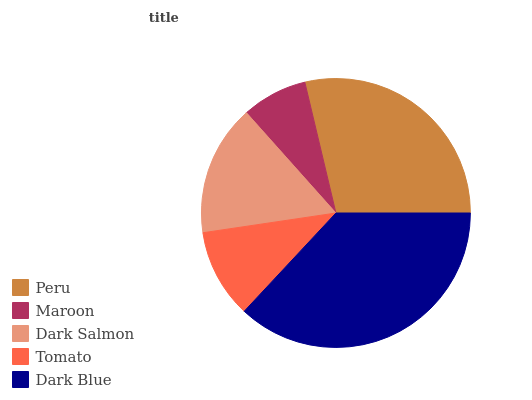Is Maroon the minimum?
Answer yes or no. Yes. Is Dark Blue the maximum?
Answer yes or no. Yes. Is Dark Salmon the minimum?
Answer yes or no. No. Is Dark Salmon the maximum?
Answer yes or no. No. Is Dark Salmon greater than Maroon?
Answer yes or no. Yes. Is Maroon less than Dark Salmon?
Answer yes or no. Yes. Is Maroon greater than Dark Salmon?
Answer yes or no. No. Is Dark Salmon less than Maroon?
Answer yes or no. No. Is Dark Salmon the high median?
Answer yes or no. Yes. Is Dark Salmon the low median?
Answer yes or no. Yes. Is Peru the high median?
Answer yes or no. No. Is Peru the low median?
Answer yes or no. No. 